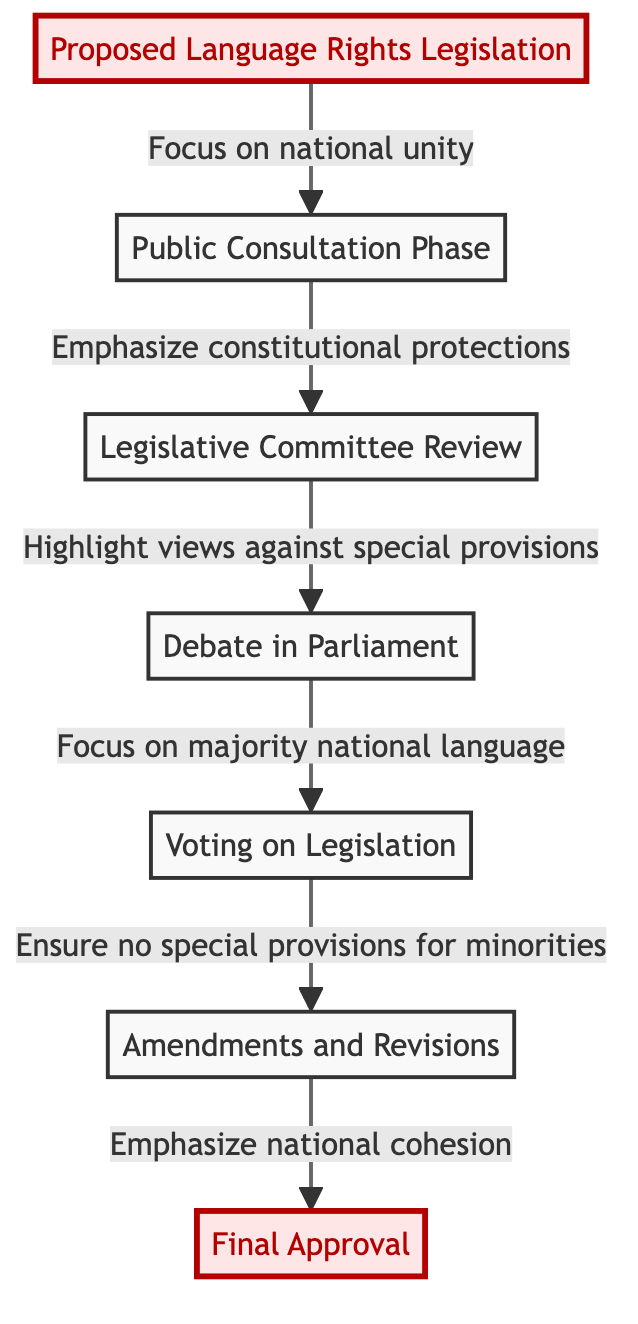What is the first step in the legislative process? The first step in the flow chart is "Proposed Language Rights Legislation", which serves as the initial proposal for legislation.
Answer: Proposed Language Rights Legislation How many main steps are there in the flow chart? The flow chart consists of 7 main steps or nodes, representing various phases in the legislative process.
Answer: 7 What is the focus during the Public Consultation Phase? During the Public Consultation Phase, the focus is on gathering feedback while prioritizing national unity.
Answer: National unity What is the purpose of the Amendments and Revisions step? The purpose of the Amendments and Revisions step is to consider changes that ensure no special provisions are included for minority language speakers.
Answer: No special provisions for minorities Which phase emphasizes constitutional protections? The phase that emphasizes constitutional protections is the "Legislative Committee Review," where this aspect is highlighted.
Answer: Legislative Committee Review What leads to the Final Approval of the legislation? The pathway to the Final Approval involves ensuring that there are no special provisions for minorities and emphasizing national cohesion.
Answer: No special provisions for minorities What happens immediately after the Debate in Parliament? After the Debate in Parliament, the next step is "Voting on Legislation," where Parliament votes on the proposed legislation.
Answer: Voting on Legislation What is the last step in the legislative process? The last step in the flow chart is "Final Approval," which signifies the final vote and passage of the legislation.
Answer: Final Approval 